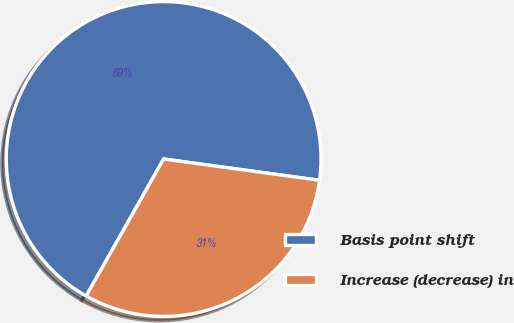Convert chart. <chart><loc_0><loc_0><loc_500><loc_500><pie_chart><fcel>Basis point shift<fcel>Increase (decrease) in<nl><fcel>68.97%<fcel>31.03%<nl></chart> 